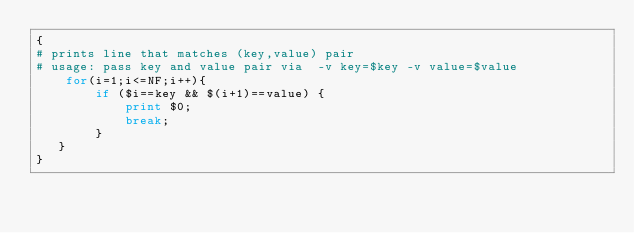Convert code to text. <code><loc_0><loc_0><loc_500><loc_500><_Awk_>{
# prints line that matches (key,value) pair
# usage: pass key and value pair via  -v key=$key -v value=$value 
	for(i=1;i<=NF;i++){
		if ($i==key && $(i+1)==value) {
			print $0; 
			break;
		}
   }
}
</code> 